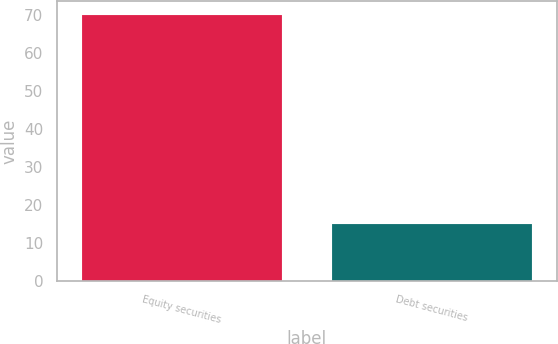Convert chart. <chart><loc_0><loc_0><loc_500><loc_500><bar_chart><fcel>Equity securities<fcel>Debt securities<nl><fcel>70<fcel>15<nl></chart> 